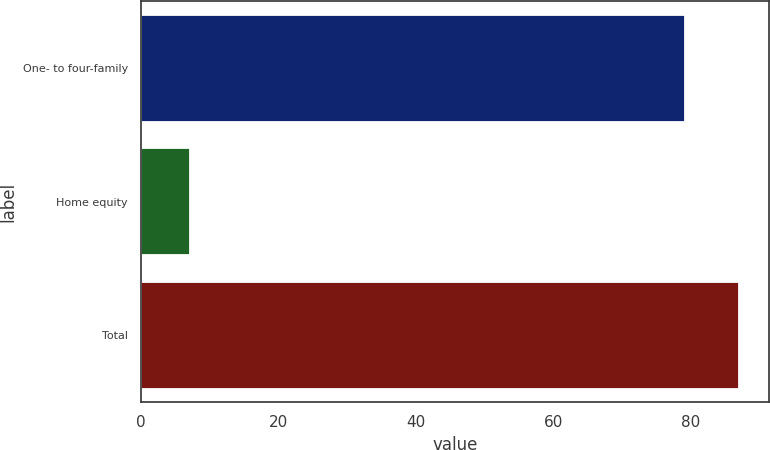<chart> <loc_0><loc_0><loc_500><loc_500><bar_chart><fcel>One- to four-family<fcel>Home equity<fcel>Total<nl><fcel>79.1<fcel>7.1<fcel>87.01<nl></chart> 